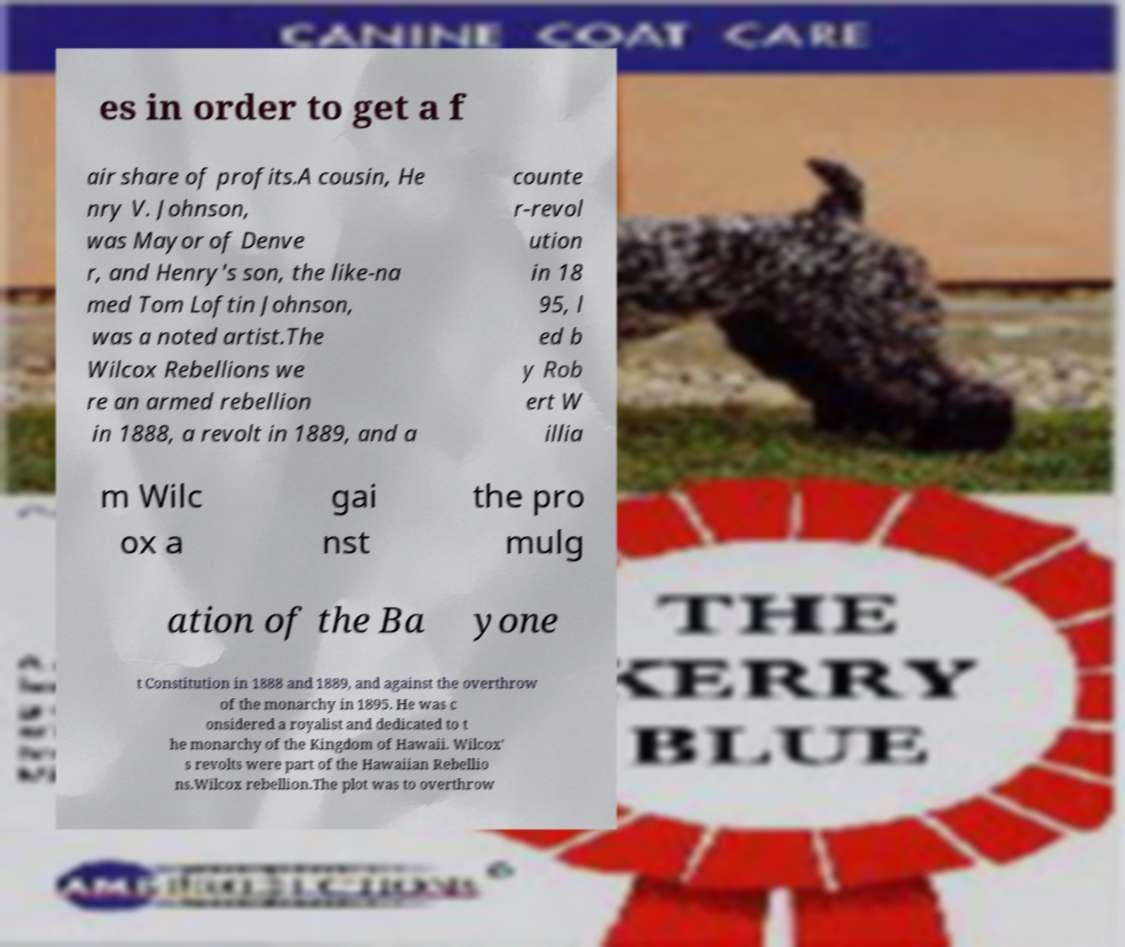Please read and relay the text visible in this image. What does it say? es in order to get a f air share of profits.A cousin, He nry V. Johnson, was Mayor of Denve r, and Henry's son, the like-na med Tom Loftin Johnson, was a noted artist.The Wilcox Rebellions we re an armed rebellion in 1888, a revolt in 1889, and a counte r-revol ution in 18 95, l ed b y Rob ert W illia m Wilc ox a gai nst the pro mulg ation of the Ba yone t Constitution in 1888 and 1889, and against the overthrow of the monarchy in 1895. He was c onsidered a royalist and dedicated to t he monarchy of the Kingdom of Hawaii. Wilcox' s revolts were part of the Hawaiian Rebellio ns.Wilcox rebellion.The plot was to overthrow 